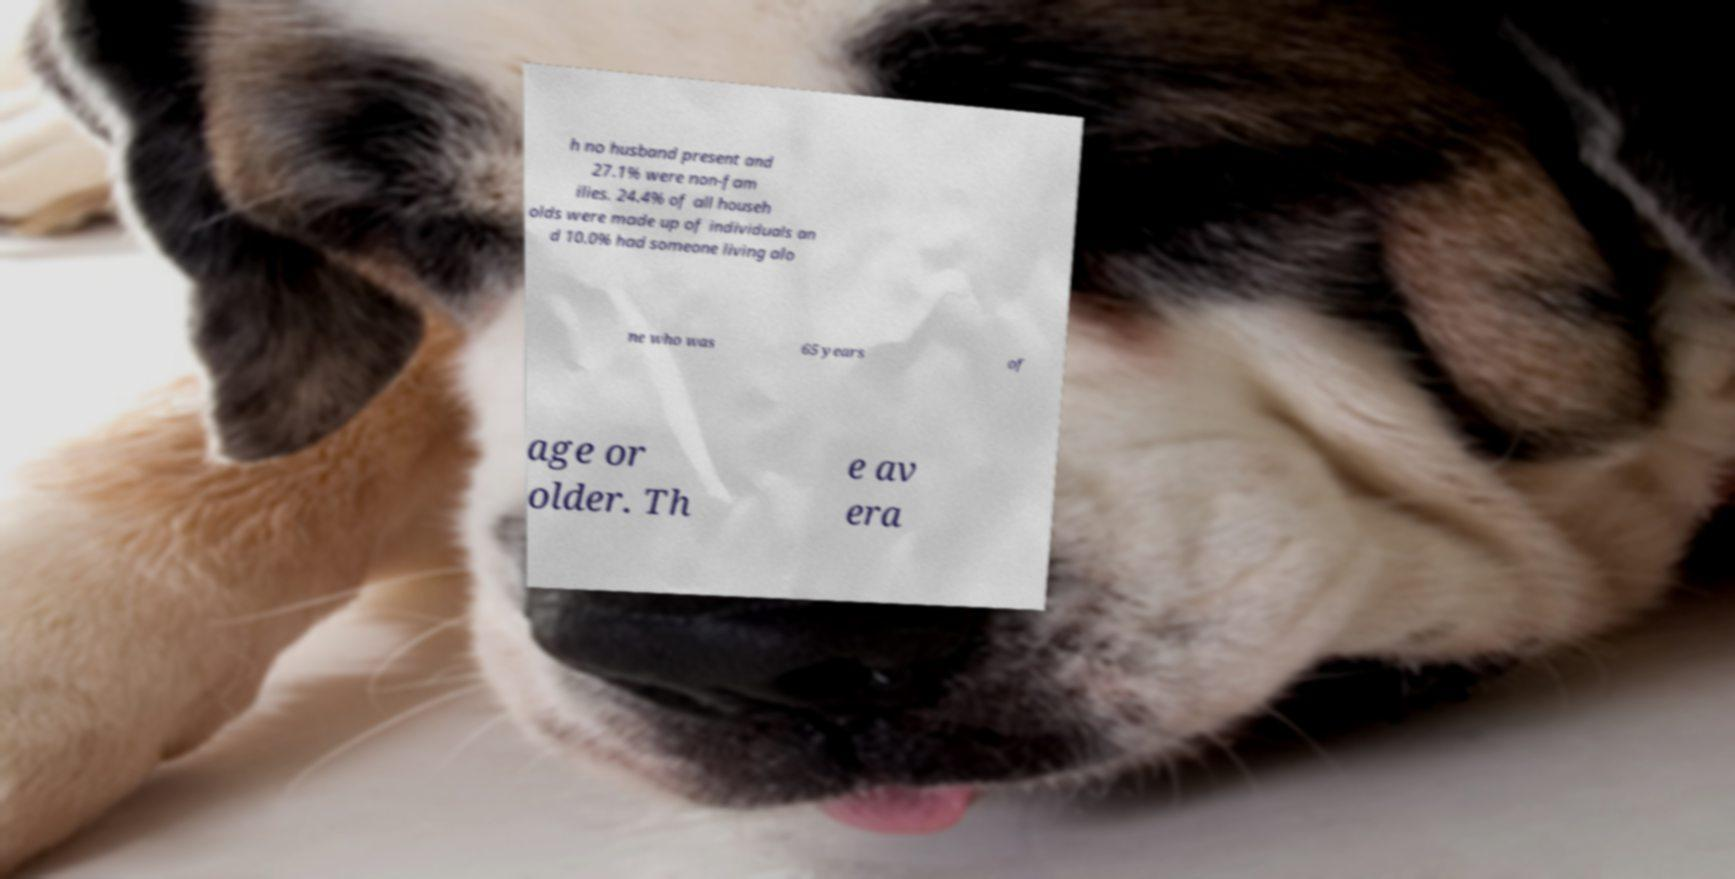Can you accurately transcribe the text from the provided image for me? h no husband present and 27.1% were non-fam ilies. 24.4% of all househ olds were made up of individuals an d 10.0% had someone living alo ne who was 65 years of age or older. Th e av era 